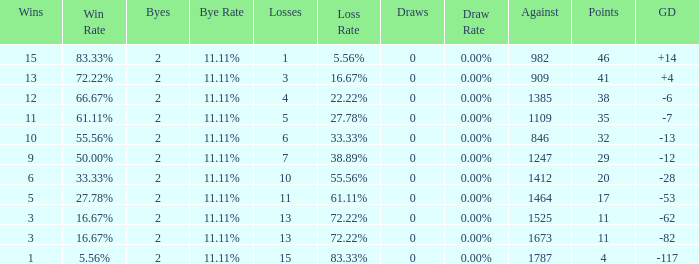What is the mean quantity of byes when there were fewer than 0 losses and were against 1247? None. 